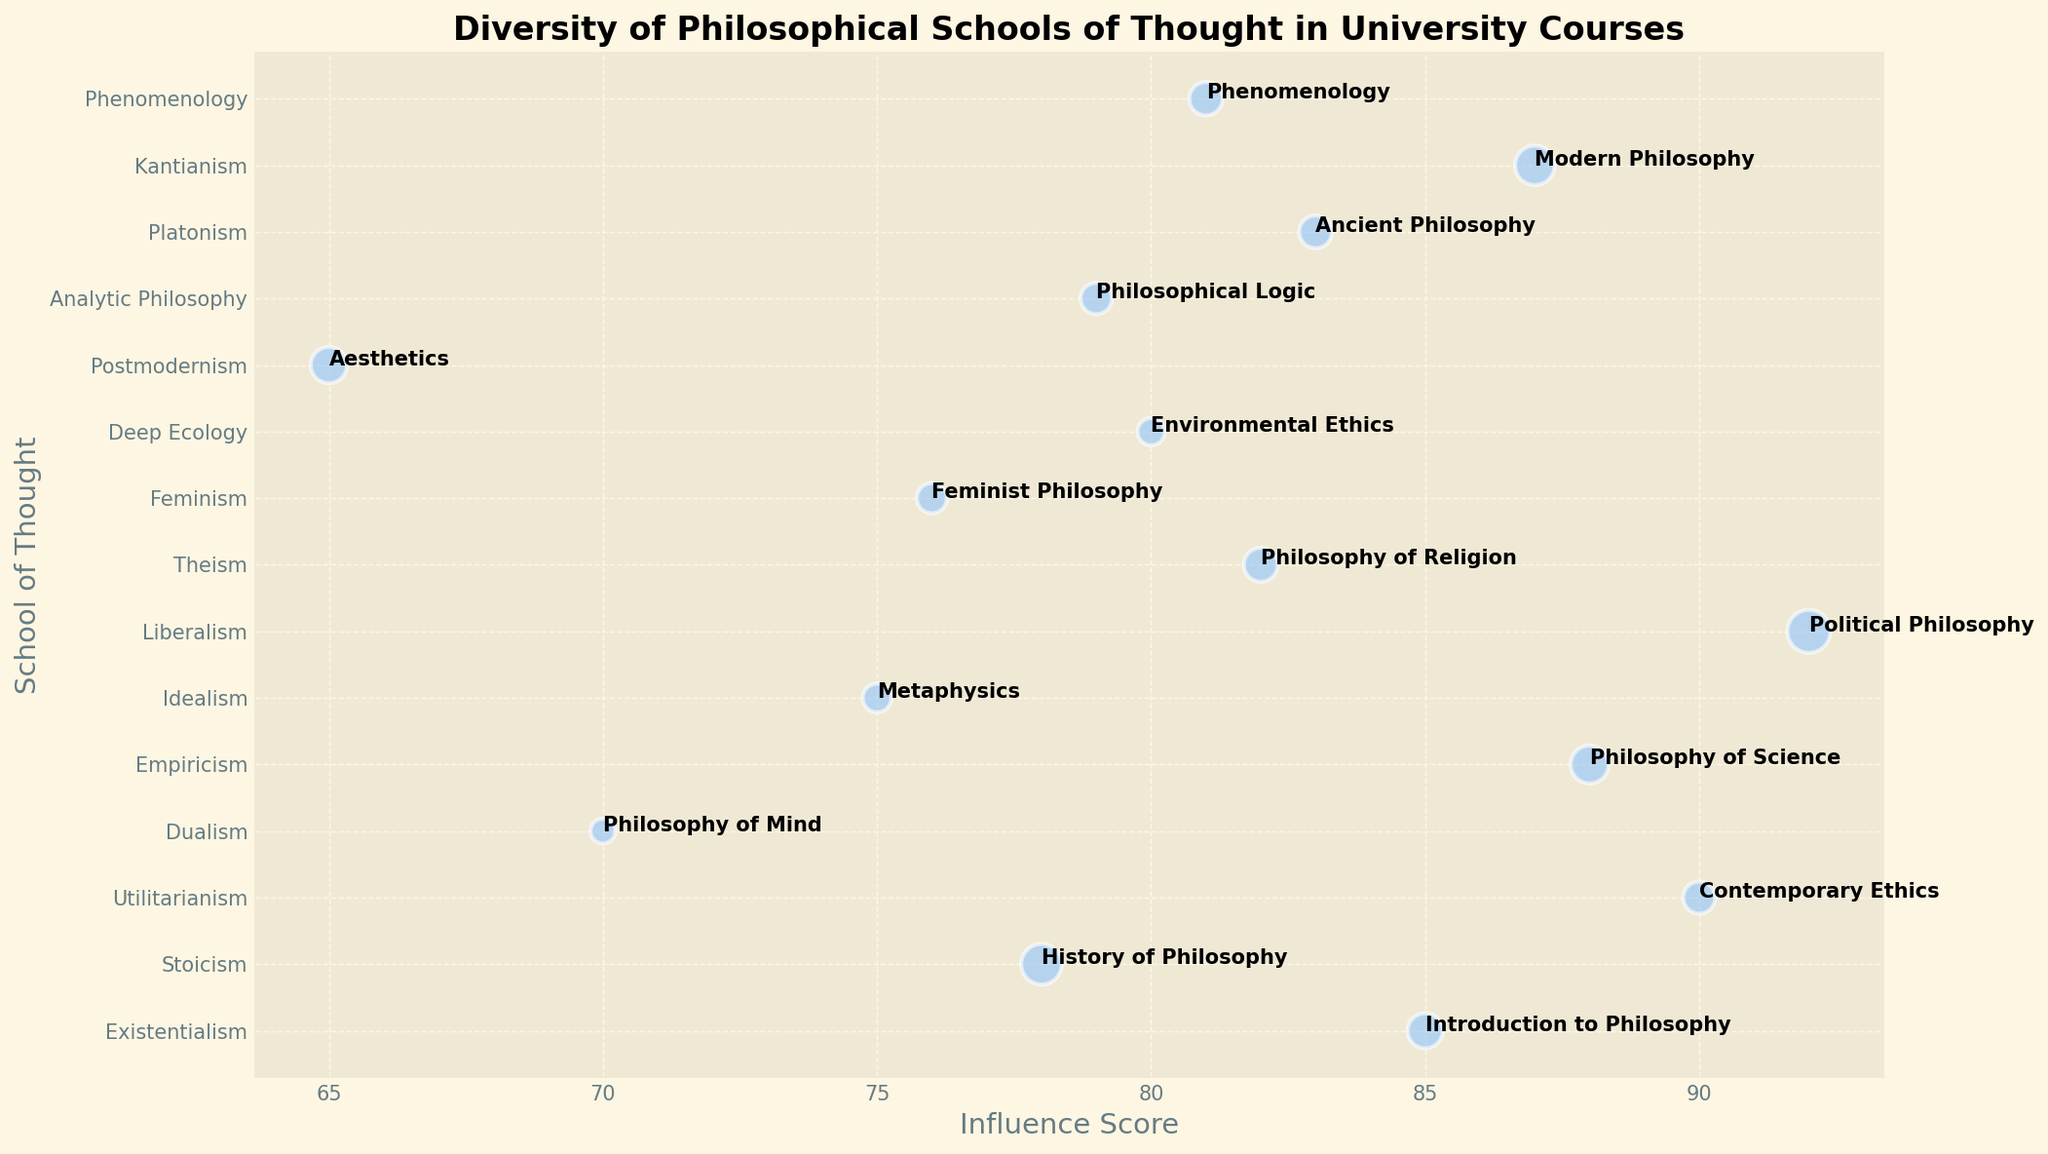How many schools of thought have influence scores greater than 80? Check the Influence Score axis and count the number of points labeled with an Influence Score greater than 80. There are seven such points: Existentialism, Utilitarianism, Empiricism, Liberalism, Theism, Platonism, and Kantianism.
Answer: 7 What is the course with the highest representation, and which school of thought does it belong to? Look for the largest bubble, which indicates the highest representation size. The largest bubble corresponds to the course "Political Philosophy" associated with the school of thought "Liberalism."
Answer: Political Philosophy, Liberalism Which course associated with Feminism, and what is its influence score? Identify the "Feminism" school of thought on the y-axis, and check the associated course label and Influence Score. The course is "Feminist Philosophy" with an Influence Score of 76.
Answer: Feminist Philosophy, 76 Compare the influence scores of "History of Philosophy" and "Environmental Ethics". Which has a higher influence score and by how much? Look at the Influence Scores for "Stoicism" and "Deep Ecology", associated with "History of Philosophy" (78) and "Environmental Ethics" (80), respectively. Subtract the former from the latter to find the difference (80 - 78).
Answer: Environmental Ethics by 2 Which school of thought has the smallest representation, and what is the influence score of the associated course? Locate the smallest bubble on the plot. The smallest bubble corresponds to "Philosophy of Mind" with the school of thought "Dualism" and an influence score of 70.
Answer: Dualism, 70 What is the average influence score of courses with a representation greater than 30? Identify courses with representations greater than 30: "Introduction to Philosophy", "History of Philosophy", "Philosophy of Science", "Political Philosophy", and "Modern Philosophy." Sum their influence scores (85 + 78 + 88 + 92 + 87) and divide by their count (5). (85 + 78 + 88 + 92 + 87) / 5 = 86
Answer: 86 Is the influence score of "Philosophy of Religion" greater than "Phenomenology"? By how much? Check the Influence Score of "Philosophy of Religion" and "Phenomenology" which are 82 and 81 respectively. Subtract the latter from the former to get the difference (82 - 81).
Answer: Yes, by 1 What is the combined representation of "Aesthetics" and "Phenomenology"? Add the representation values of "Aesthetics" (32) and "Phenomenology" (27). 32 + 27 = 59
Answer: 59 